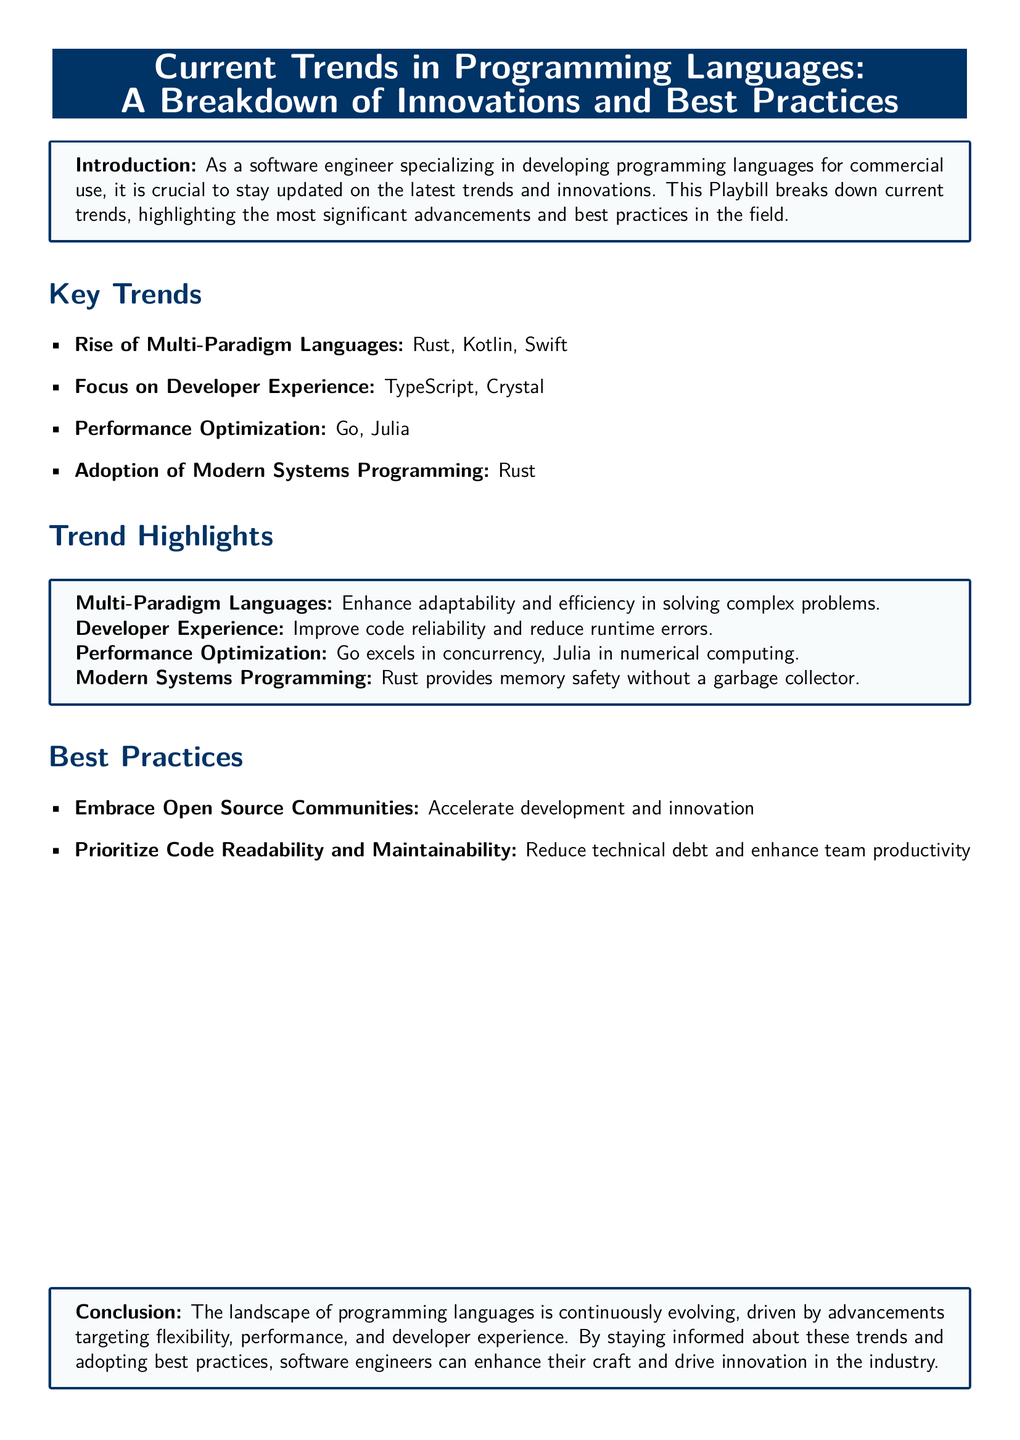What is the title of the Playbill? The title is mentioned in a centered format at the top of the document as "Current Trends in Programming Languages: A Breakdown of Innovations and Best Practices."
Answer: Current Trends in Programming Languages: A Breakdown of Innovations and Best Practices How many key trends are listed? The document provides a list of key trends in a bullet format, which includes four distinct items.
Answer: Four Which programming language is noted for performance optimization in concurrency? The specifics of performance optimization point to Go as excelling in concurrency within the trend highlights section.
Answer: Go What is one benefit of embracing open source communities? The text states that embracing open source communities accelerates development and innovation, which is a clear benefit outlined in the best practices.
Answer: Accelerate development and innovation What does Rust provide according to the trend highlights? The document specifies that Rust provides memory safety without a garbage collector, emphasizing its role in modern systems programming.
Answer: Memory safety without a garbage collector Which programming language is highlighted for its developer experience? TypeScript is explicitly mentioned in the key trends section for its focus on improving developer experience.
Answer: TypeScript What is the conclusion emphasizing about programming languages? The conclusion highlights the continuous evolution of programming languages driven by advancements targeting flexibility, performance, and developer experience.
Answer: Continuous evolution What genre does this document belong to? This type of document is characterized as a Playbill, which is indicated at the beginning of the content.
Answer: Playbill 